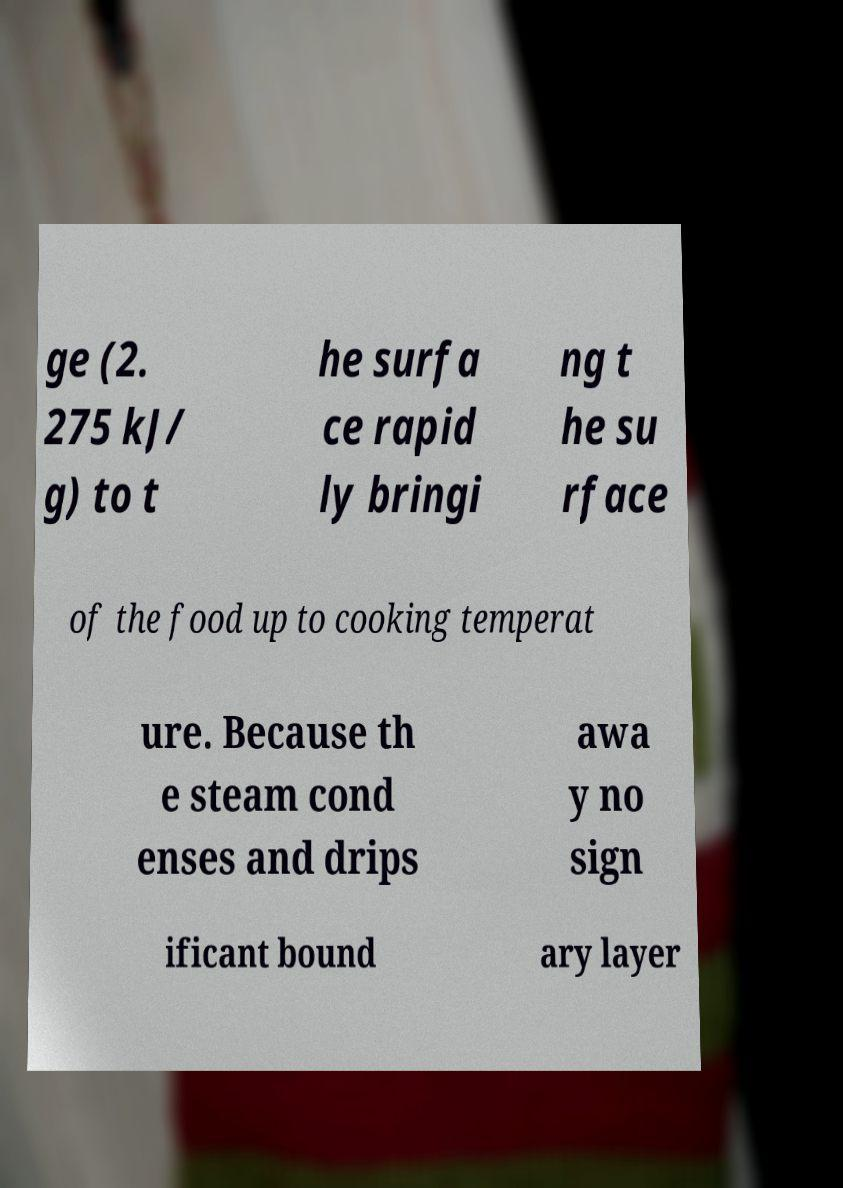Can you read and provide the text displayed in the image?This photo seems to have some interesting text. Can you extract and type it out for me? ge (2. 275 kJ/ g) to t he surfa ce rapid ly bringi ng t he su rface of the food up to cooking temperat ure. Because th e steam cond enses and drips awa y no sign ificant bound ary layer 